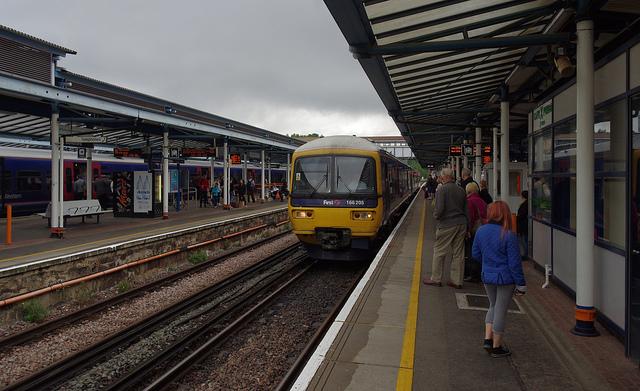Is the train ' s headlights on?
Answer briefly. Yes. How many colors is the train?
Keep it brief. 2. Where are the people standing?
Give a very brief answer. Train station. Is there woman in this photo?
Give a very brief answer. Yes. Are some of the people wearing reflective vests?
Give a very brief answer. No. Are there any people in the image?
Write a very short answer. Yes. What direction are most people walking?
Quick response, please. Away. Is it a sunny day outside?
Be succinct. No. Is the platform empty?
Concise answer only. No. Is the woman in the blue jacket wearing shorts?
Answer briefly. No. 